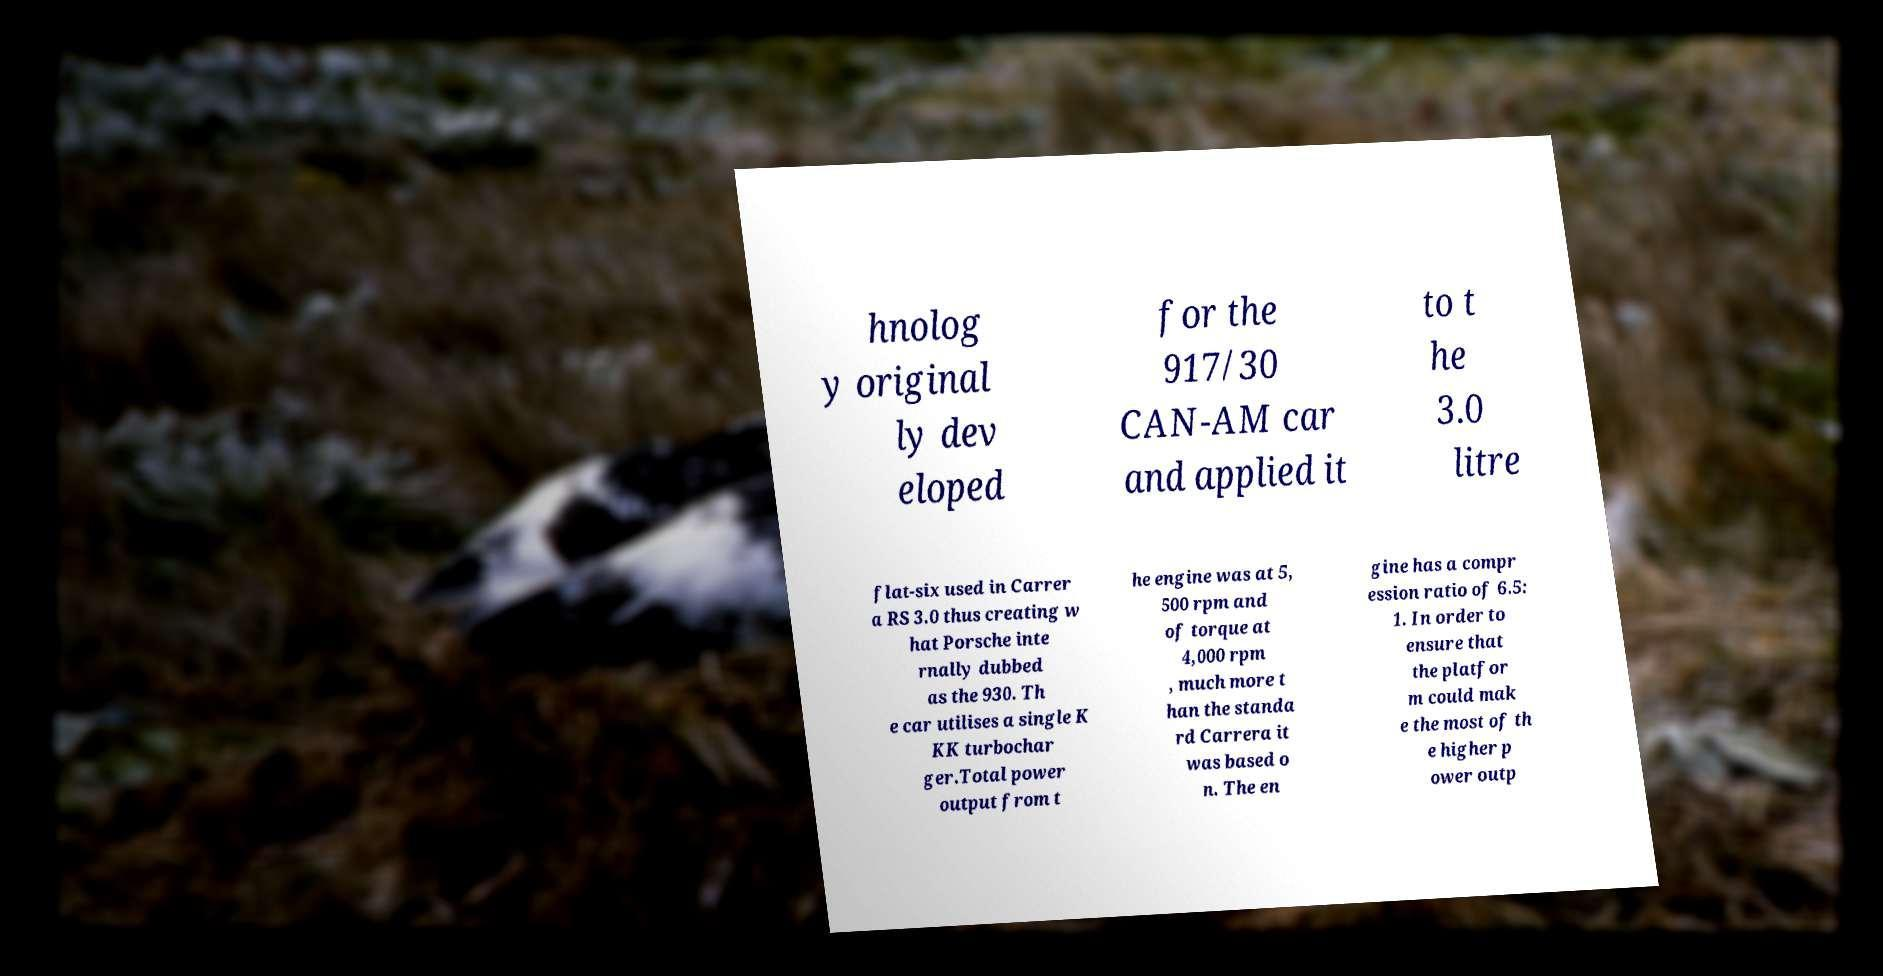I need the written content from this picture converted into text. Can you do that? hnolog y original ly dev eloped for the 917/30 CAN-AM car and applied it to t he 3.0 litre flat-six used in Carrer a RS 3.0 thus creating w hat Porsche inte rnally dubbed as the 930. Th e car utilises a single K KK turbochar ger.Total power output from t he engine was at 5, 500 rpm and of torque at 4,000 rpm , much more t han the standa rd Carrera it was based o n. The en gine has a compr ession ratio of 6.5: 1. In order to ensure that the platfor m could mak e the most of th e higher p ower outp 